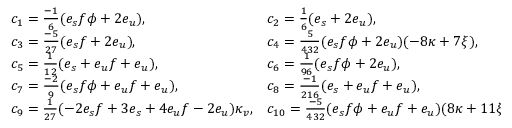<formula> <loc_0><loc_0><loc_500><loc_500>\begin{array} { l l } { { c _ { 1 } = { \frac { - 1 } { 6 } } ( e _ { s } f \phi + 2 e _ { u } ) , } } & { { c _ { 2 } = { \frac { 1 } { 6 } } ( e _ { s } + 2 e _ { u } ) , } } \\ { { c _ { 3 } = { \frac { - 5 } { 2 7 } } ( e _ { s } f + 2 e _ { u } ) , } } & { { c _ { 4 } = { \frac { 5 } { 4 3 2 } } ( e _ { s } f \phi + 2 e _ { u } ) ( - 8 \kappa + 7 \xi ) , } } \\ { { c _ { 5 } = { \frac { 1 } { 1 2 } } ( e _ { s } + e _ { u } f + e _ { u } ) , } } & { { c _ { 6 } = { \frac { 1 } { 9 6 } } ( e _ { s } f \phi + 2 e _ { u } ) , } } \\ { { c _ { 7 } = { \frac { - 2 } { 9 } } ( e _ { s } f \phi + e _ { u } f + e _ { u } ) , } } & { { c _ { 8 } = { \frac { - 1 } { 2 1 6 } } ( e _ { s } + e _ { u } f + e _ { u } ) , } } \\ { { c _ { 9 } = { \frac { 1 } { 2 7 } } ( - 2 e _ { s } f + 3 e _ { s } + 4 e _ { u } f - 2 e _ { u } ) \kappa _ { v } , } } & { { c _ { 1 0 } = { \frac { - 5 } { 4 3 2 } } ( e _ { s } f \phi + e _ { u } f + e _ { u } ) ( 8 \kappa + 1 1 \xi ) , } } \end{array}</formula> 